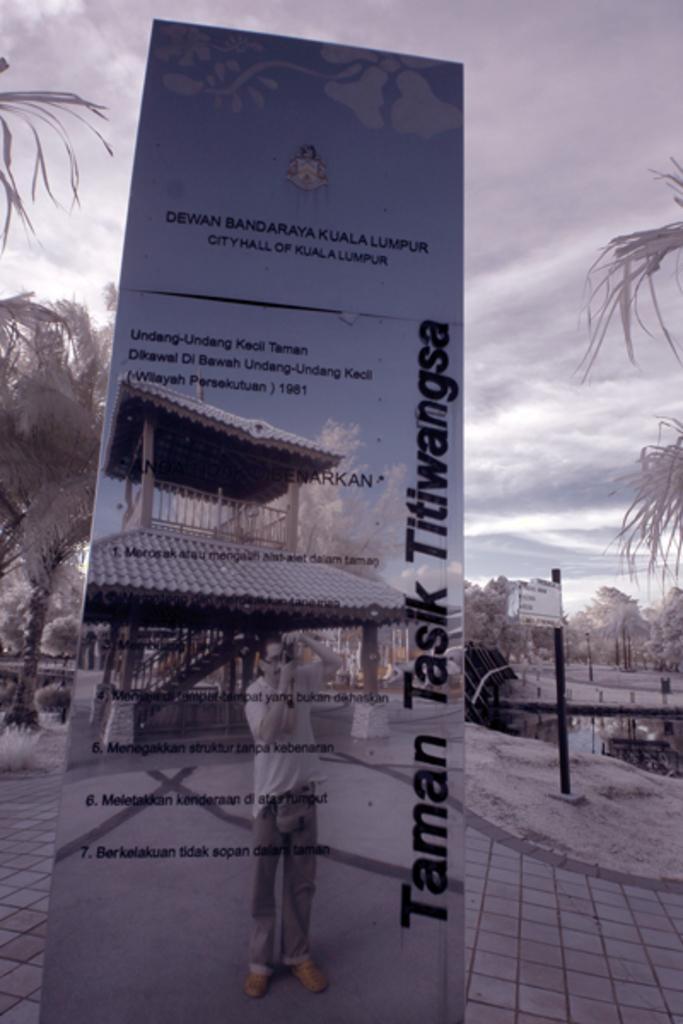How would you summarize this image in a sentence or two? In this picture, we can see a poster with some text and some images on it, we can see the ground, trees, water, poles and the sky with clouds. 